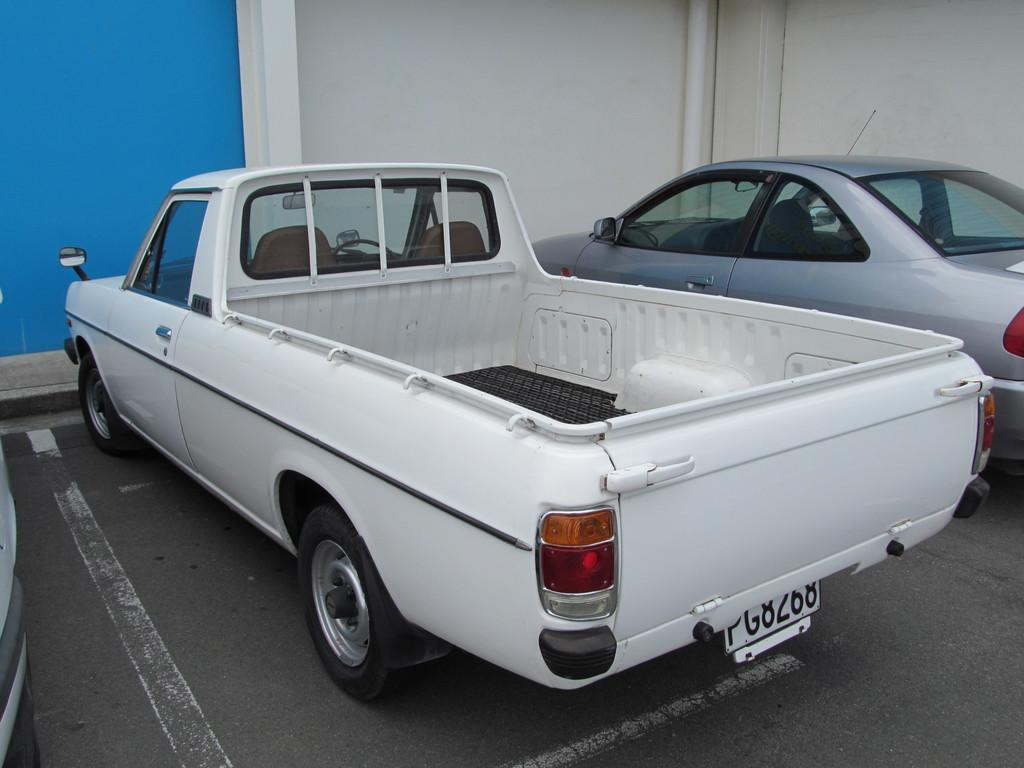What can be seen on the road in the image? There are vehicles on the road in the image. Can you describe any specific features of the wall visible in the image? The wall has a blue and white color in the image. What type of sign can be seen on the wall in the image? There is no sign visible on the wall in the image. Can you tell me how many worms are crawling on the vehicles in the image? There are no worms present in the image; it only features vehicles on the road. 